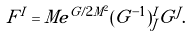<formula> <loc_0><loc_0><loc_500><loc_500>F ^ { I } = M e ^ { G / 2 M ^ { 2 } } ( G ^ { - 1 } ) _ { J } ^ { I } G ^ { J } .</formula> 